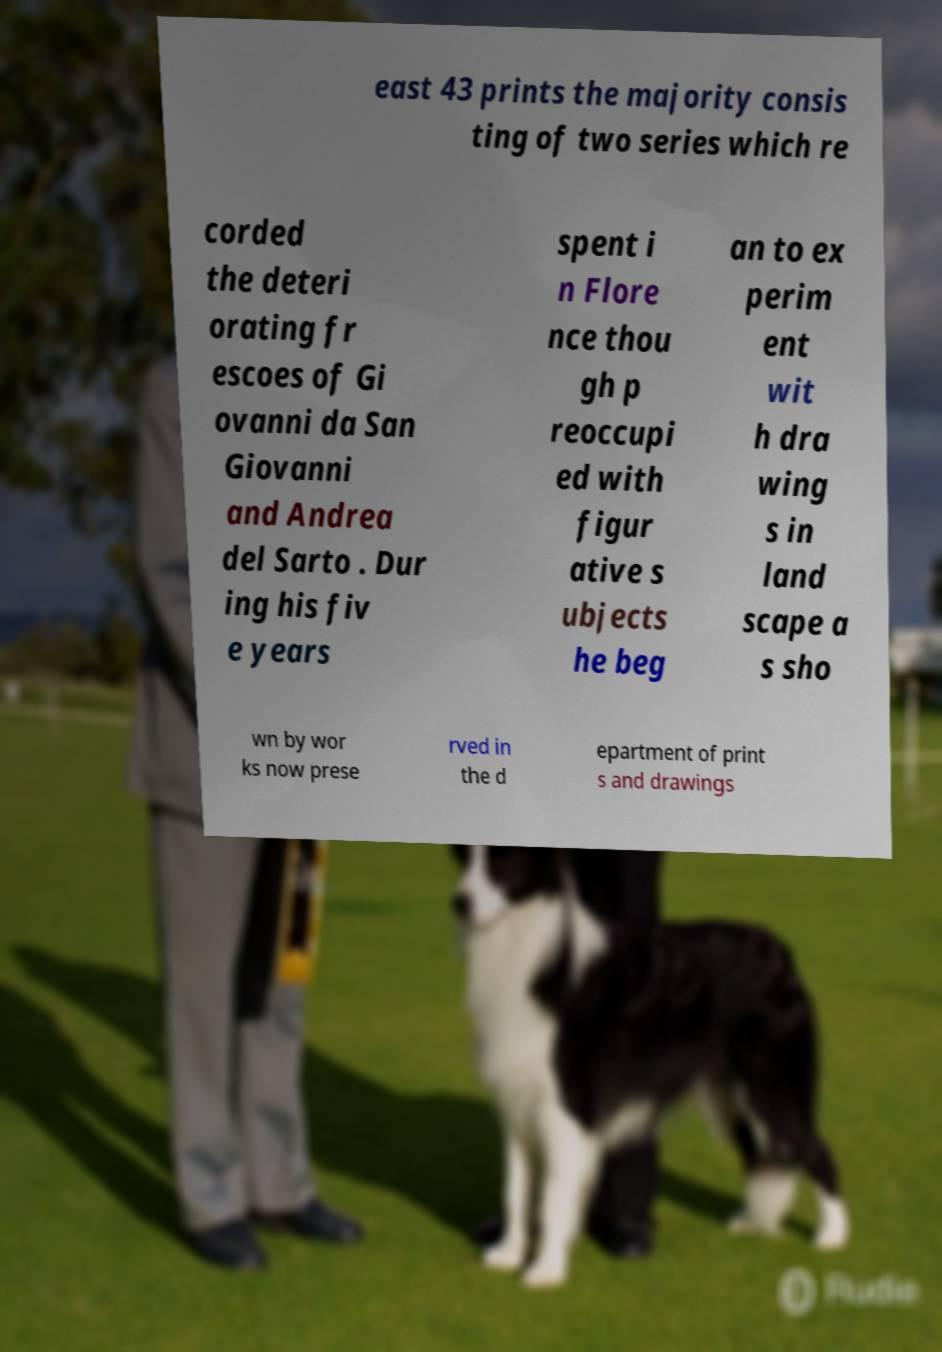Can you accurately transcribe the text from the provided image for me? east 43 prints the majority consis ting of two series which re corded the deteri orating fr escoes of Gi ovanni da San Giovanni and Andrea del Sarto . Dur ing his fiv e years spent i n Flore nce thou gh p reoccupi ed with figur ative s ubjects he beg an to ex perim ent wit h dra wing s in land scape a s sho wn by wor ks now prese rved in the d epartment of print s and drawings 